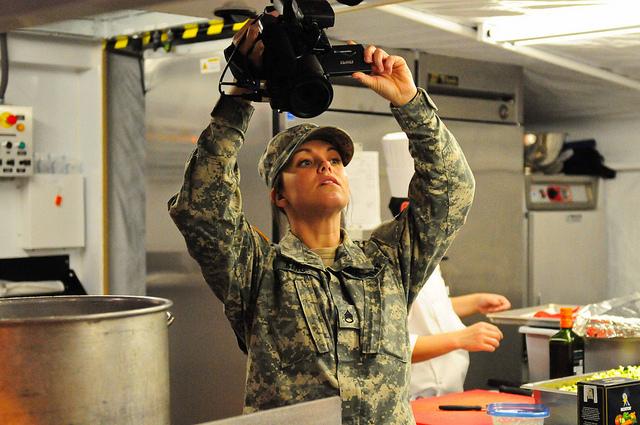What kind of uniform is she wearing?
Give a very brief answer. Army. What is the person holding?
Answer briefly. Camera. Has this person been trained to fire a gun?
Answer briefly. Yes. 